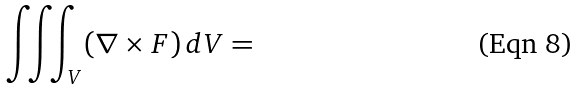<formula> <loc_0><loc_0><loc_500><loc_500>\iiint _ { V } ( \nabla \times F ) \, d V =</formula> 